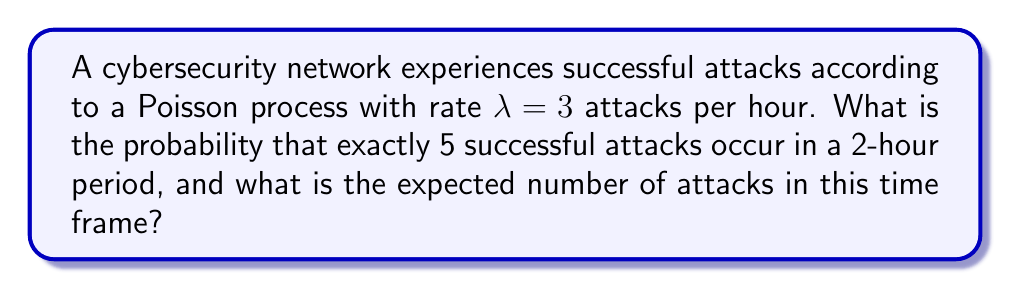Can you answer this question? To solve this problem, we'll use the properties of the Poisson process:

1. For a Poisson process with rate λ, the number of events N(t) in an interval of length t follows a Poisson distribution with parameter λt.

2. The probability mass function of a Poisson distribution with parameter μ is:

   $$P(X = k) = \frac{e^{-μ}μ^k}{k!}$$

3. The expected value of a Poisson distribution is equal to its parameter μ.

Step 1: Calculate the parameter for the 2-hour period
μ = λt = 3 attacks/hour × 2 hours = 6 attacks

Step 2: Calculate the probability of exactly 5 attacks in 2 hours
$$P(X = 5) = \frac{e^{-6}6^5}{5!}$$

$$= \frac{e^{-6} \times 7776}{120}$$

$$≈ 0.1606$$

Step 3: Calculate the expected number of attacks in 2 hours
E[X] = μ = 6 attacks

Therefore, the probability of exactly 5 successful attacks in a 2-hour period is approximately 0.1606 or 16.06%, and the expected number of attacks in this time frame is 6.
Answer: P(X = 5) ≈ 0.1606, E[X] = 6 